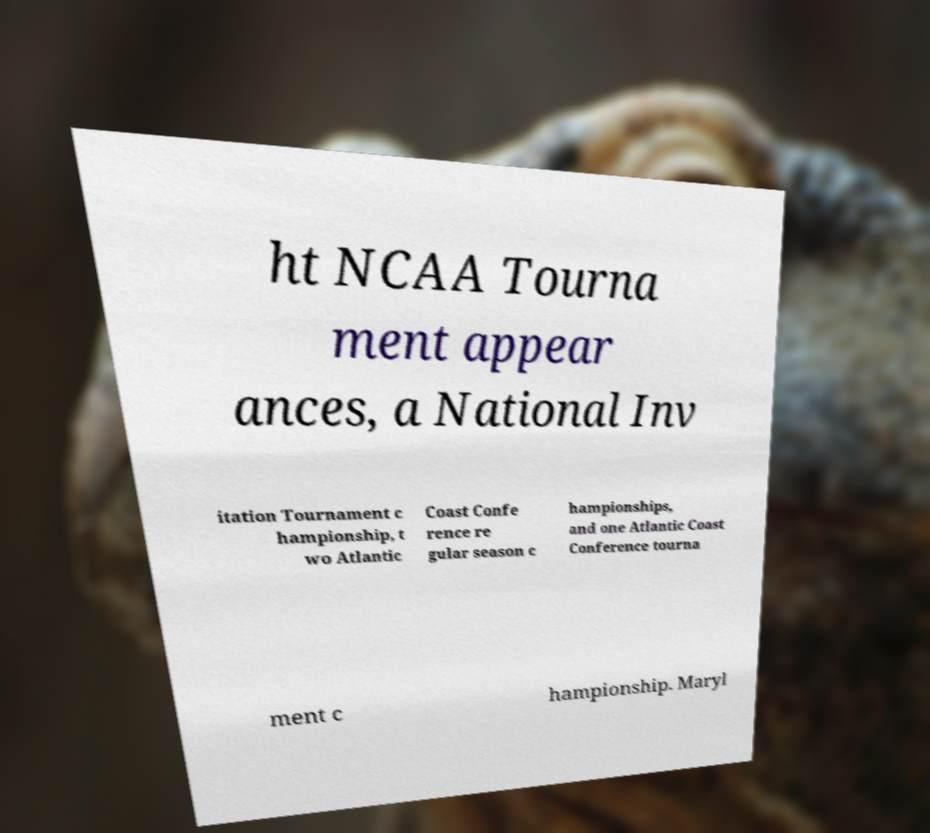What messages or text are displayed in this image? I need them in a readable, typed format. ht NCAA Tourna ment appear ances, a National Inv itation Tournament c hampionship, t wo Atlantic Coast Confe rence re gular season c hampionships, and one Atlantic Coast Conference tourna ment c hampionship. Maryl 